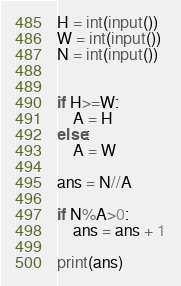<code> <loc_0><loc_0><loc_500><loc_500><_Python_>H = int(input())
W = int(input())
N = int(input())


if H>=W:
    A = H
else:
    A = W

ans = N//A

if N%A>0:
    ans = ans + 1

print(ans)</code> 